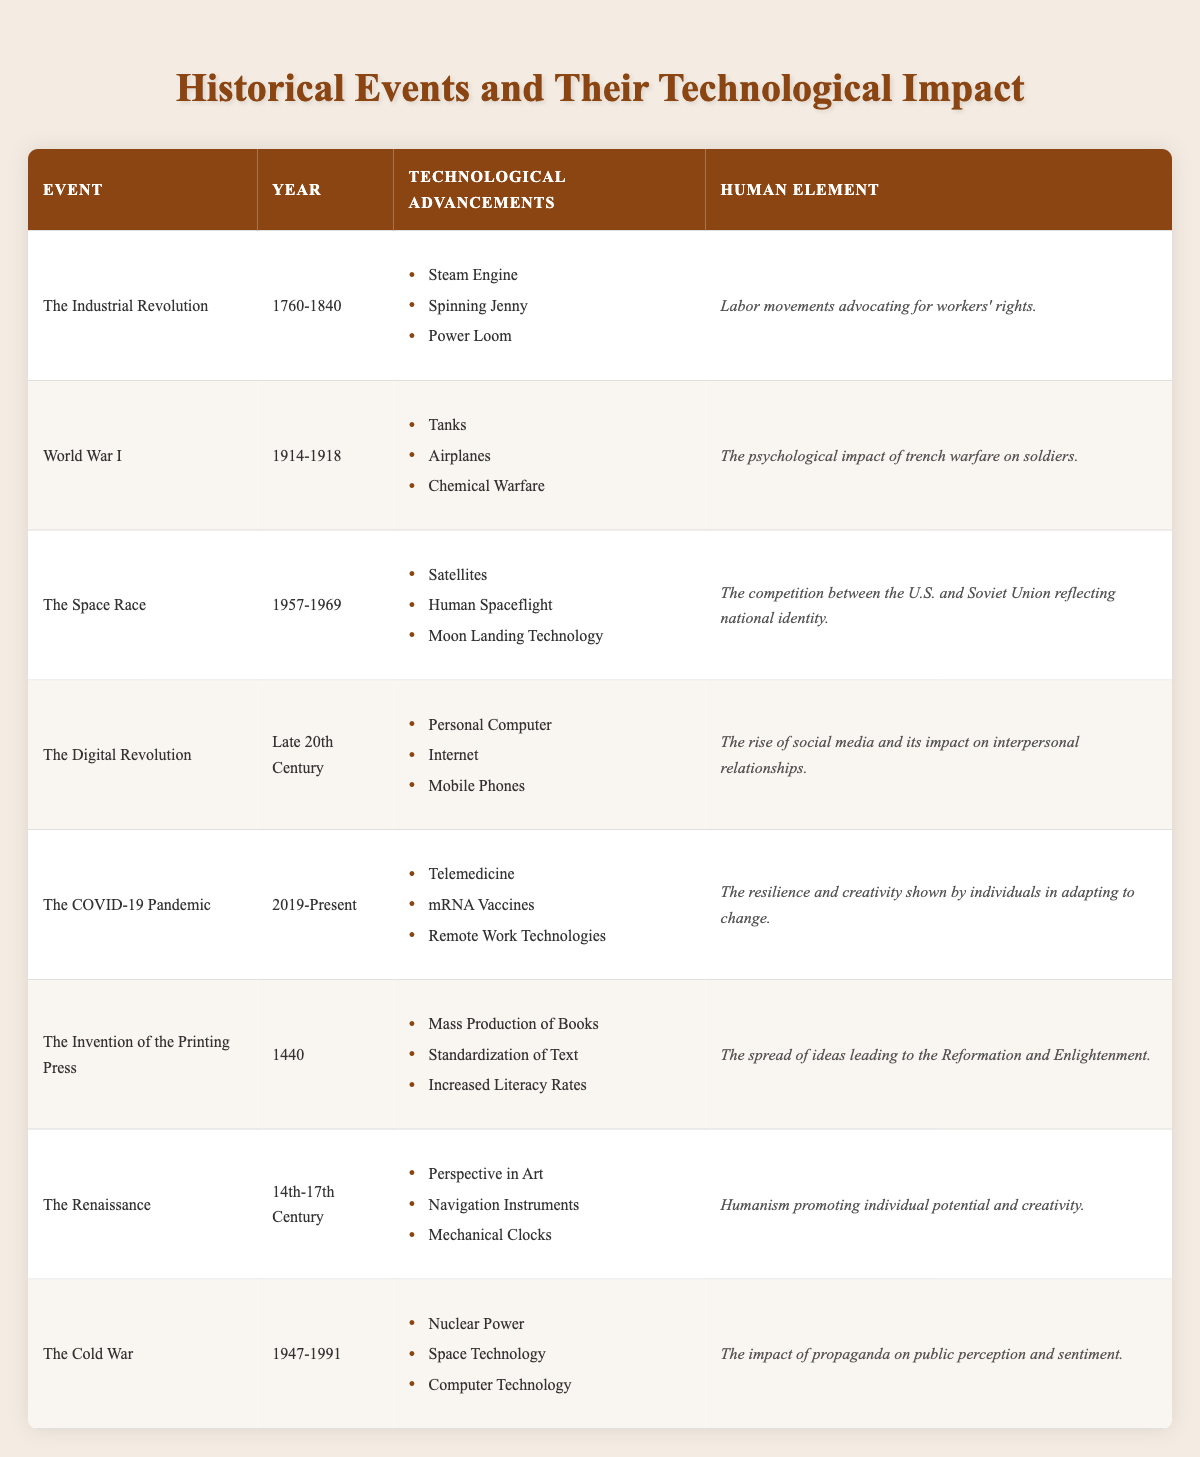What technological advancements occurred during the Industrial Revolution? The table lists three specific advancements under the Industrial Revolution. They are the Steam Engine, Spinning Jenny, and Power Loom.
Answer: Steam Engine, Spinning Jenny, Power Loom Which event had the most psychological impact on individuals but no technological advancements? Looking through the human element column, the event with a significant psychological impact without accompanying technological advancements is primarily represented by World War I, as it focused on the psychological impact of trench warfare.
Answer: World War I Was the printing press invented before or after the Renaissance period? The table shows the invention of the printing press in 1440, while the Renaissance spans from the 14th to 17th century, which indicates that the printing press was invented before this period.
Answer: Before Count how many technological advancements were introduced during the Digital Revolution and the COVID-19 Pandemic combined. The Digital Revolution mentions three advancements: Personal Computer, Internet, and Mobile Phones. The COVID-19 Pandemic also lists three: Telemedicine, mRNA Vaccines, and Remote Work Technologies. Adding these together gives a total of 3 + 3 = 6 advancements.
Answer: 6 Did the Cold War introduce any advancements related to space technology? By examining the row for the Cold War, one of the listed technological advancements is indeed Space Technology, confirming the introduction of such advancements.
Answer: Yes Which event had the most pronounced effect on increasing literacy rates? By reviewing the table, the event that specifically states an increase in literacy rates is the Invention of the Printing Press, which corresponds directly with its listed human element about spreading ideas that led to increased literacy.
Answer: The Invention of the Printing Press Compare the human elements of the Space Race and the Cold War. What is their difference? The Space Race reflects national identity due to competition between the U.S. and Soviet Union, while the Cold War's impact is framed around propaganda affecting public perception. The difference lies in the focus on national identity versus the influence of propaganda itself.
Answer: Difference in focus: national identity vs. propaganda How many events mentioned the technological advancement of computers? The term "Computer Technology" appears in two events: The Digital Revolution and The Cold War. Therefore, there are two events that mention computer technologies.
Answer: 2 